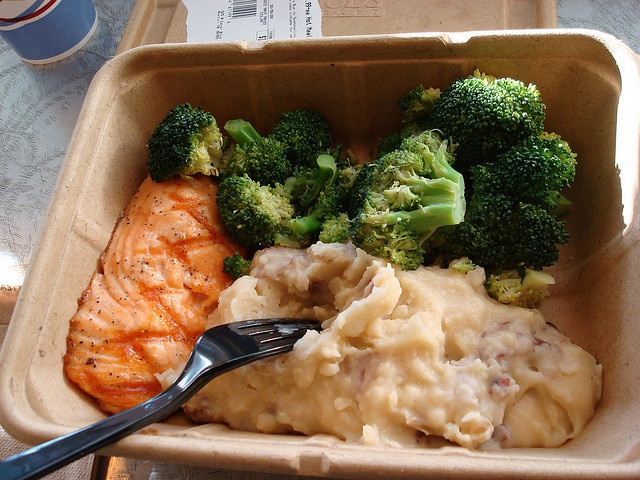Describe the objects in this image and their specific colors. I can see bowl in black, maroon, tan, and olive tones, broccoli in maroon, black, olive, and darkgreen tones, fork in maroon, black, gray, navy, and blue tones, and cup in maroon, blue, darkblue, darkgray, and gray tones in this image. 